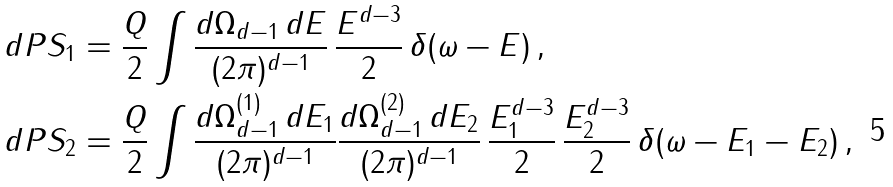Convert formula to latex. <formula><loc_0><loc_0><loc_500><loc_500>d P S _ { 1 } & = \frac { Q } { 2 } \int \frac { d \Omega _ { d - 1 } \, d E } { ( 2 \pi ) ^ { d - 1 } } \, \frac { E ^ { d - 3 } } { 2 } \, \delta ( \omega - E ) \, , \\ d P S _ { 2 } & = \frac { Q } { 2 } \int \frac { d \Omega _ { d - 1 } ^ { ( 1 ) } \, d E _ { 1 } } { ( 2 \pi ) ^ { d - 1 } } \frac { d \Omega _ { d - 1 } ^ { ( 2 ) } \, d E _ { 2 } } { ( 2 \pi ) ^ { d - 1 } } \, \frac { E _ { 1 } ^ { d - 3 } } { 2 } \, \frac { E _ { 2 } ^ { d - 3 } } { 2 } \, \delta ( \omega - E _ { 1 } - E _ { 2 } ) \, ,</formula> 